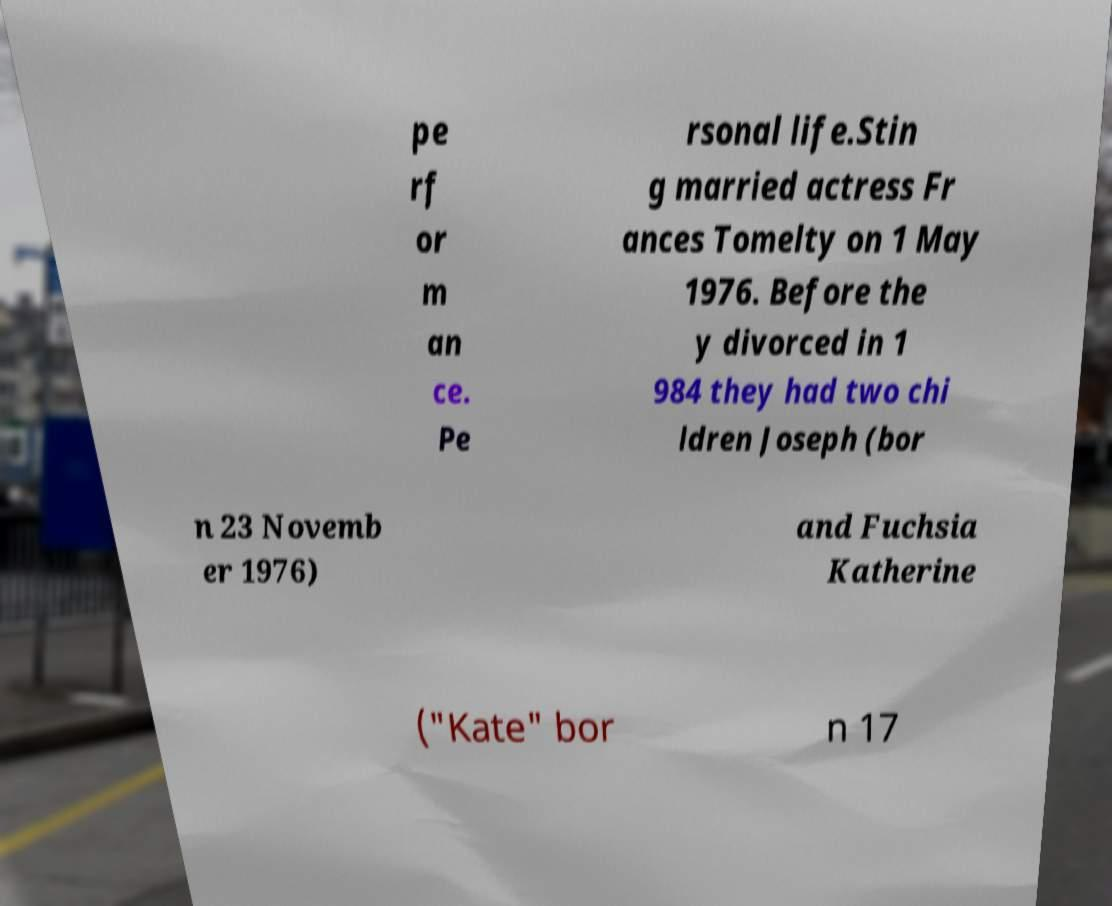For documentation purposes, I need the text within this image transcribed. Could you provide that? pe rf or m an ce. Pe rsonal life.Stin g married actress Fr ances Tomelty on 1 May 1976. Before the y divorced in 1 984 they had two chi ldren Joseph (bor n 23 Novemb er 1976) and Fuchsia Katherine ("Kate" bor n 17 